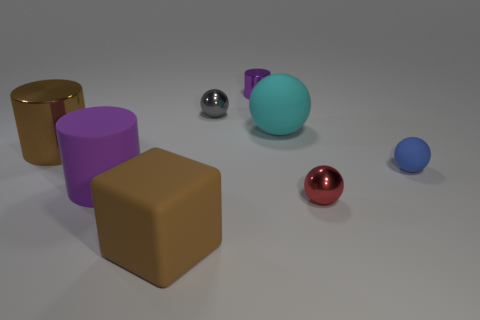Subtract 1 balls. How many balls are left? 3 Subtract all yellow balls. Subtract all yellow cubes. How many balls are left? 4 Add 1 brown rubber blocks. How many objects exist? 9 Subtract all cubes. How many objects are left? 7 Subtract 0 gray cylinders. How many objects are left? 8 Subtract all cyan rubber objects. Subtract all tiny gray things. How many objects are left? 6 Add 8 cyan objects. How many cyan objects are left? 9 Add 2 small blue cylinders. How many small blue cylinders exist? 2 